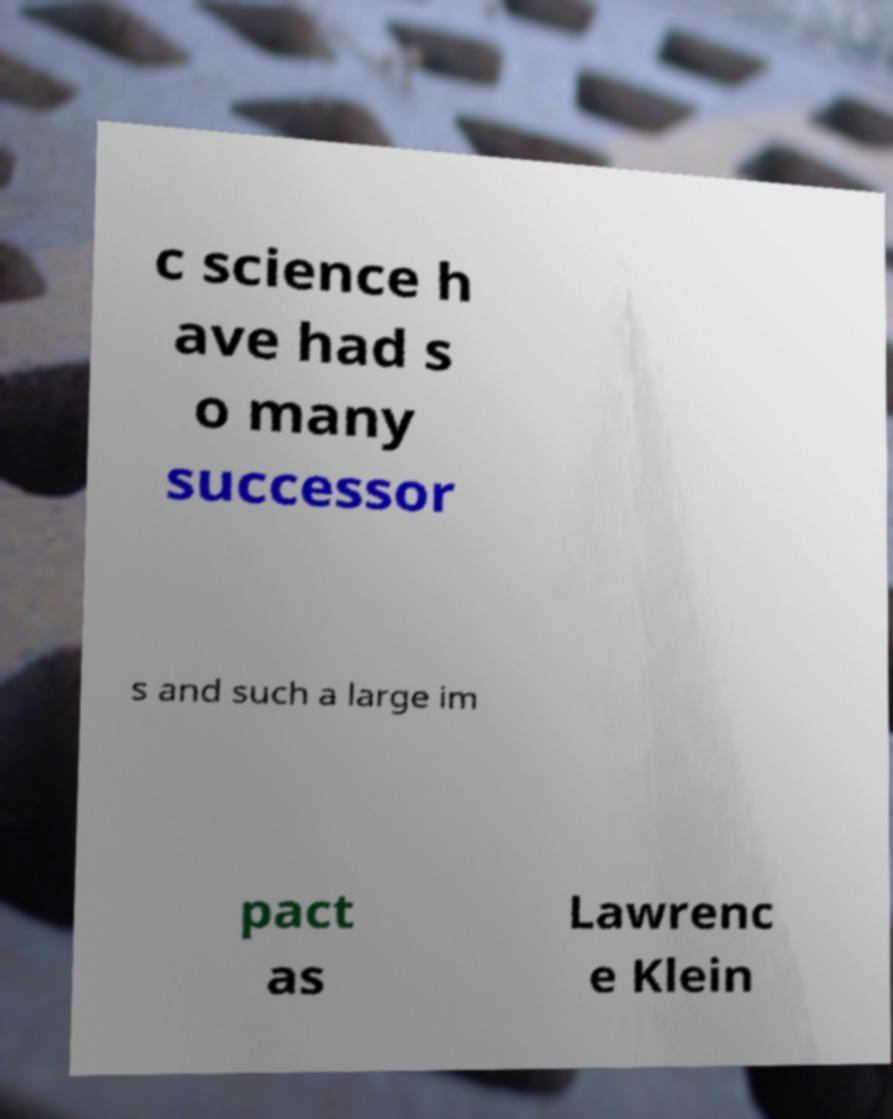Could you extract and type out the text from this image? c science h ave had s o many successor s and such a large im pact as Lawrenc e Klein 